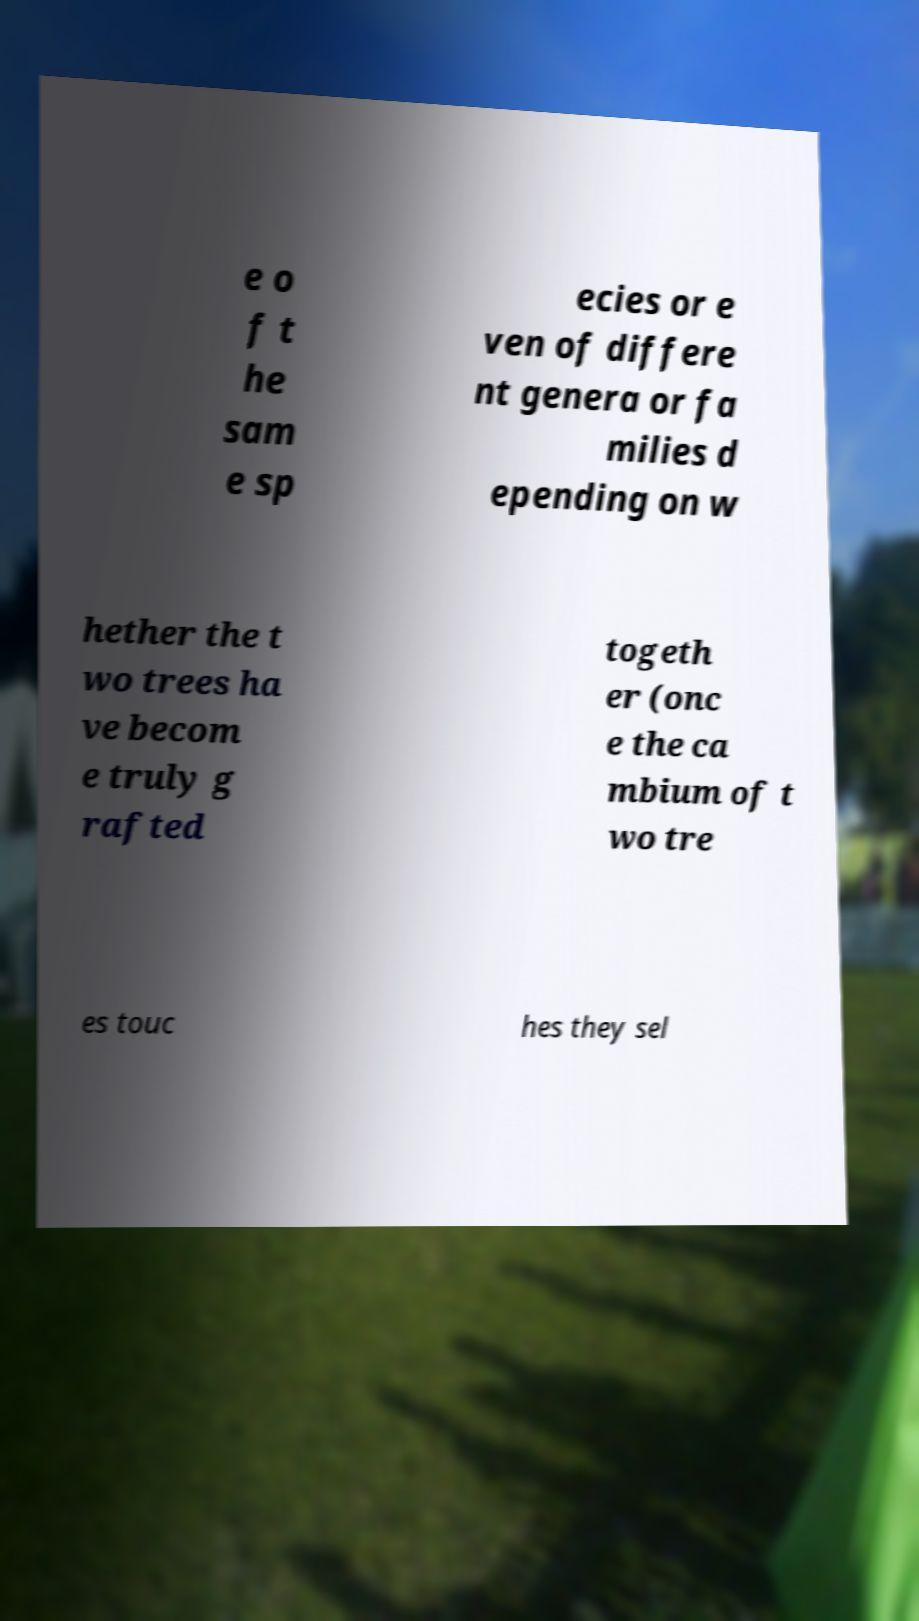I need the written content from this picture converted into text. Can you do that? e o f t he sam e sp ecies or e ven of differe nt genera or fa milies d epending on w hether the t wo trees ha ve becom e truly g rafted togeth er (onc e the ca mbium of t wo tre es touc hes they sel 